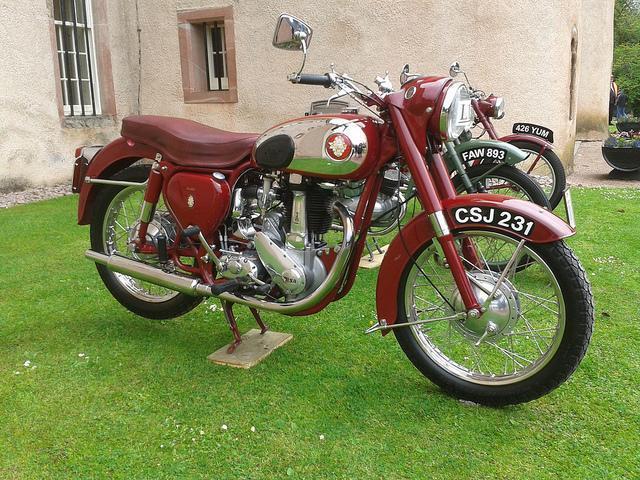How many bikes are the same color?
Give a very brief answer. 2. How many motorcycles are there?
Give a very brief answer. 2. 